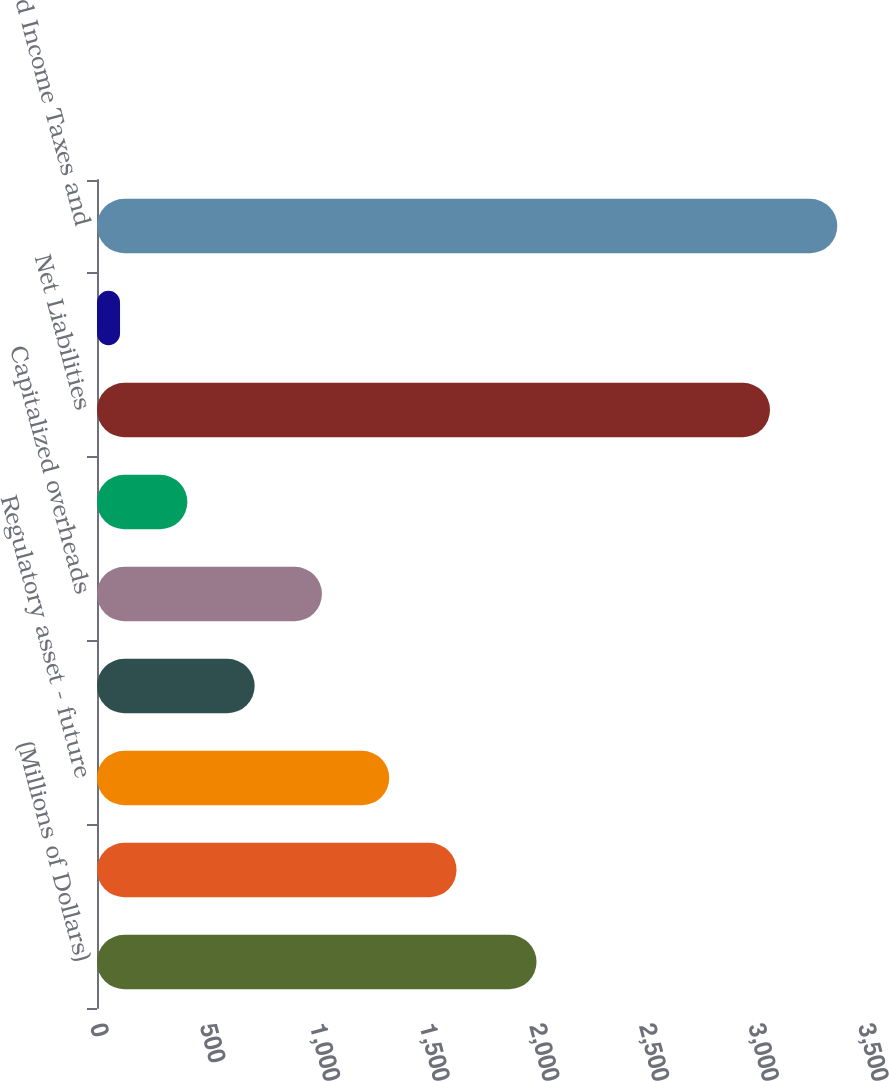Convert chart. <chart><loc_0><loc_0><loc_500><loc_500><bar_chart><fcel>(Millions of Dollars)<fcel>Depreciation<fcel>Regulatory asset - future<fcel>State income tax<fcel>Capitalized overheads<fcel>Other<fcel>Net Liabilities<fcel>Investment Tax Credits<fcel>Deferred Income Taxes and<nl><fcel>2003<fcel>1638.5<fcel>1331.8<fcel>718.4<fcel>1025.1<fcel>411.7<fcel>3067<fcel>105<fcel>3373.7<nl></chart> 